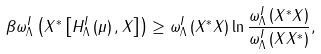<formula> <loc_0><loc_0><loc_500><loc_500>\beta \omega _ { \Lambda } ^ { I } \left ( X ^ { * } \left [ H _ { \Lambda } ^ { I } \left ( \mu \right ) , X \right ] \right ) \geq \omega _ { \Lambda } ^ { I } \left ( X ^ { * } X \right ) \ln \frac { \omega _ { \Lambda } ^ { I } \left ( X ^ { * } X \right ) } { \omega _ { \Lambda } ^ { I } \left ( X X ^ { * } \right ) } ,</formula> 